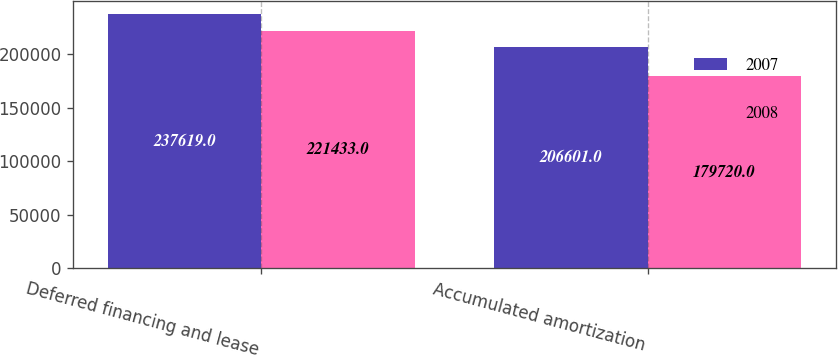Convert chart. <chart><loc_0><loc_0><loc_500><loc_500><stacked_bar_chart><ecel><fcel>Deferred financing and lease<fcel>Accumulated amortization<nl><fcel>2007<fcel>237619<fcel>206601<nl><fcel>2008<fcel>221433<fcel>179720<nl></chart> 